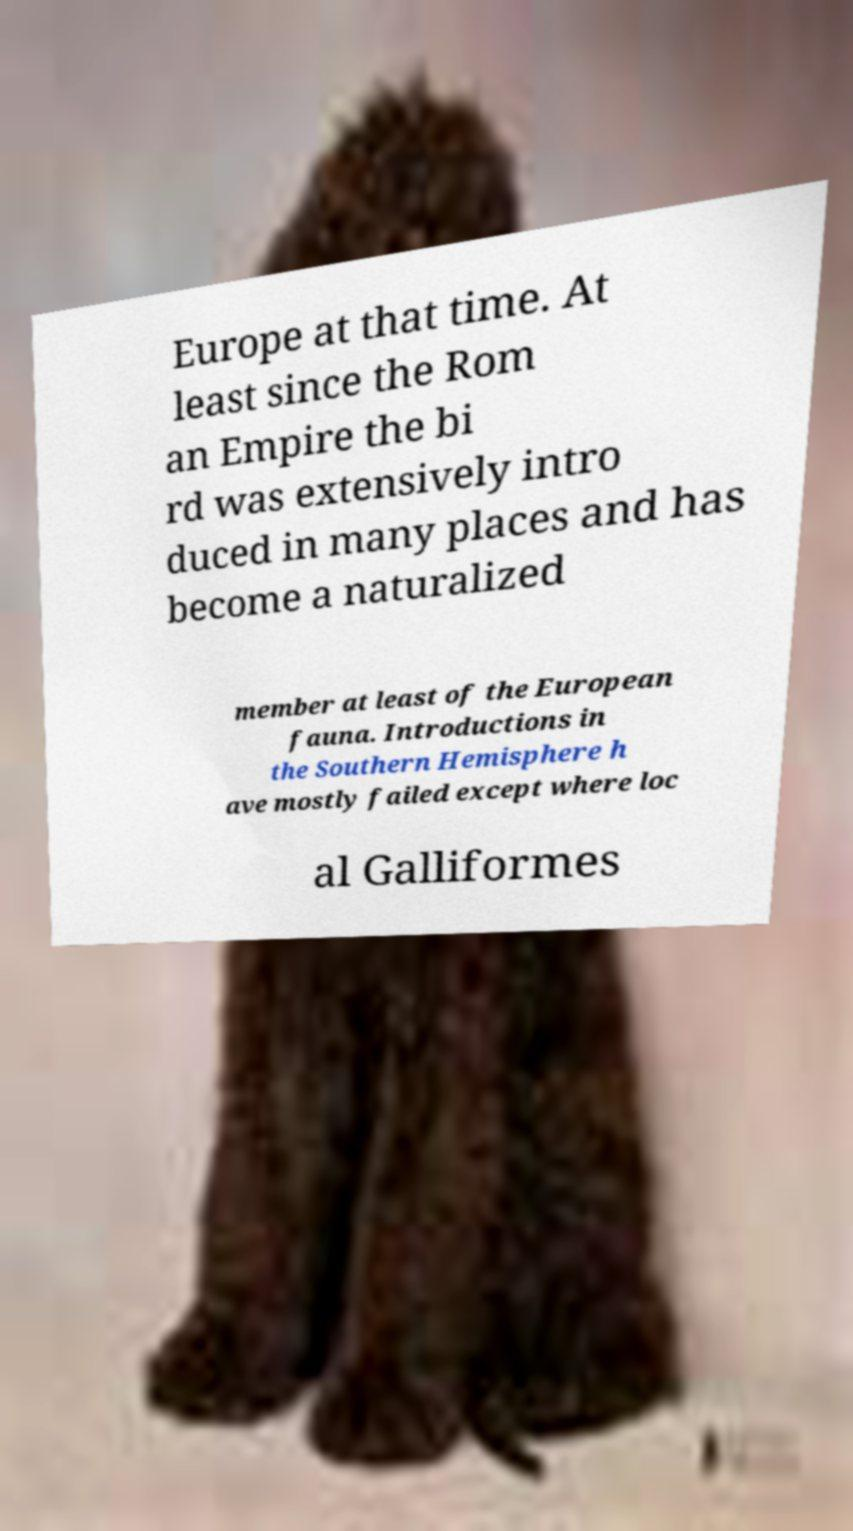Could you assist in decoding the text presented in this image and type it out clearly? Europe at that time. At least since the Rom an Empire the bi rd was extensively intro duced in many places and has become a naturalized member at least of the European fauna. Introductions in the Southern Hemisphere h ave mostly failed except where loc al Galliformes 